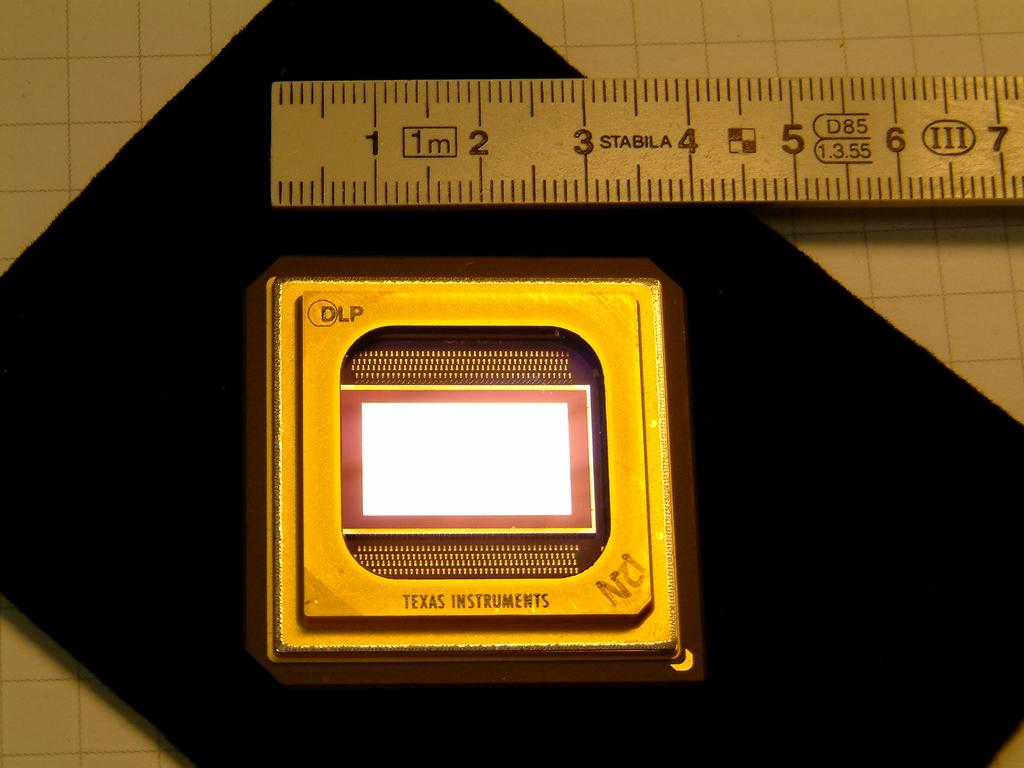How long is this device?
Ensure brevity in your answer.  4 inches. What state is on this item?
Ensure brevity in your answer.  Texas. 